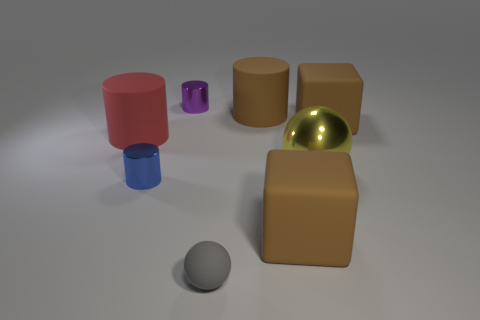Subtract all purple shiny cylinders. How many cylinders are left? 3 Subtract all blue cylinders. How many cylinders are left? 3 Subtract 2 cylinders. How many cylinders are left? 2 Add 1 small green rubber cylinders. How many objects exist? 9 Subtract all green cylinders. Subtract all blue cubes. How many cylinders are left? 4 Subtract all balls. How many objects are left? 6 Subtract all gray things. Subtract all shiny cylinders. How many objects are left? 5 Add 6 small blue objects. How many small blue objects are left? 7 Add 3 tiny metal cylinders. How many tiny metal cylinders exist? 5 Subtract 0 green cylinders. How many objects are left? 8 